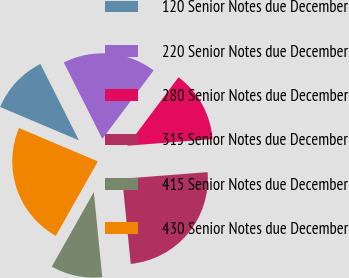Convert chart to OTSL. <chart><loc_0><loc_0><loc_500><loc_500><pie_chart><fcel>120 Senior Notes due December<fcel>220 Senior Notes due December<fcel>280 Senior Notes due December<fcel>315 Senior Notes due December<fcel>415 Senior Notes due December<fcel>430 Senior Notes due December<nl><fcel>11.19%<fcel>17.66%<fcel>13.54%<fcel>24.66%<fcel>9.74%<fcel>23.21%<nl></chart> 